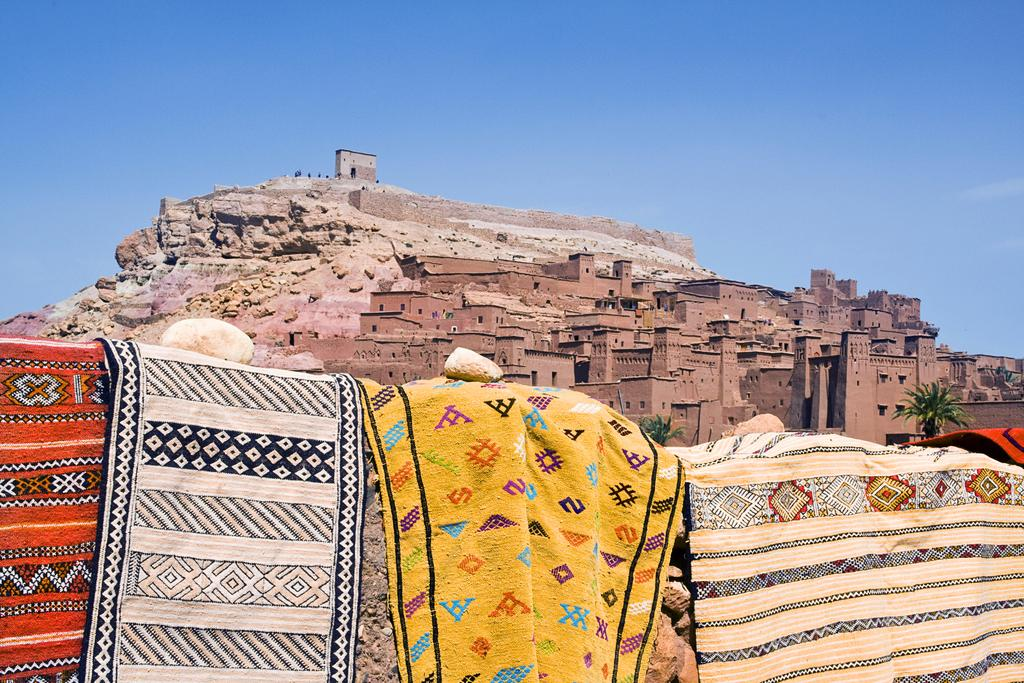What is hanging on the wall in the image? There are bed sheets on the wall in the image. What can be seen in the background of the image? There are buildings on a mountain in the background of the image. What part of the natural environment is visible in the image? The sky is visible in the image. What type of milk is being poured into the buildings on the mountain in the image? There is no milk present in the image, and the buildings on the mountain are not being affected by any liquid. 